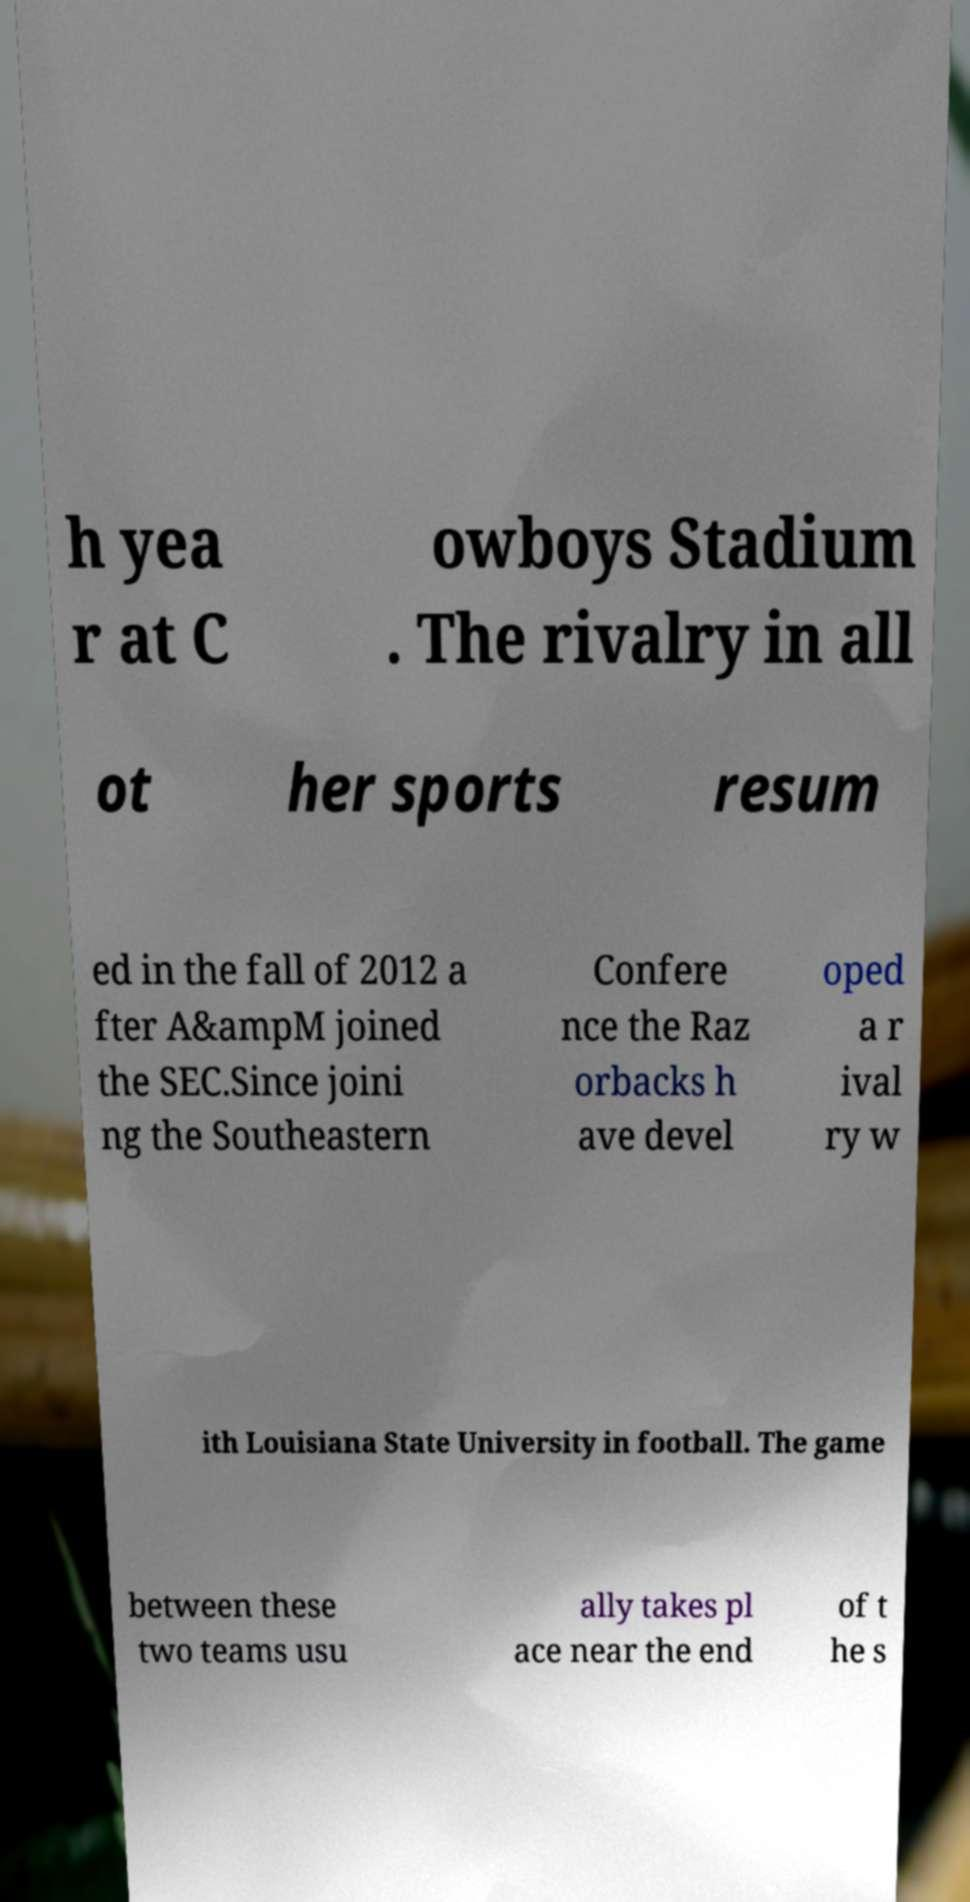There's text embedded in this image that I need extracted. Can you transcribe it verbatim? h yea r at C owboys Stadium . The rivalry in all ot her sports resum ed in the fall of 2012 a fter A&ampM joined the SEC.Since joini ng the Southeastern Confere nce the Raz orbacks h ave devel oped a r ival ry w ith Louisiana State University in football. The game between these two teams usu ally takes pl ace near the end of t he s 